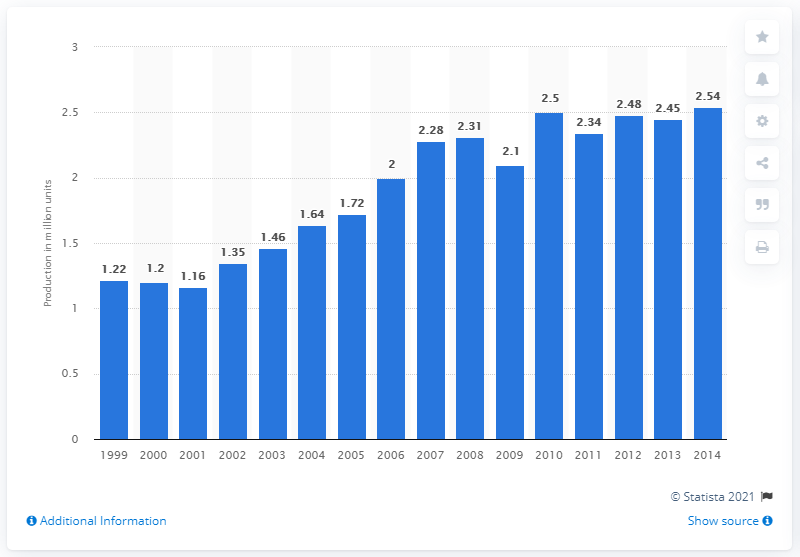Highlight a few significant elements in this photo. In 2013, Suzuki produced 2,450 passenger vehicles. 